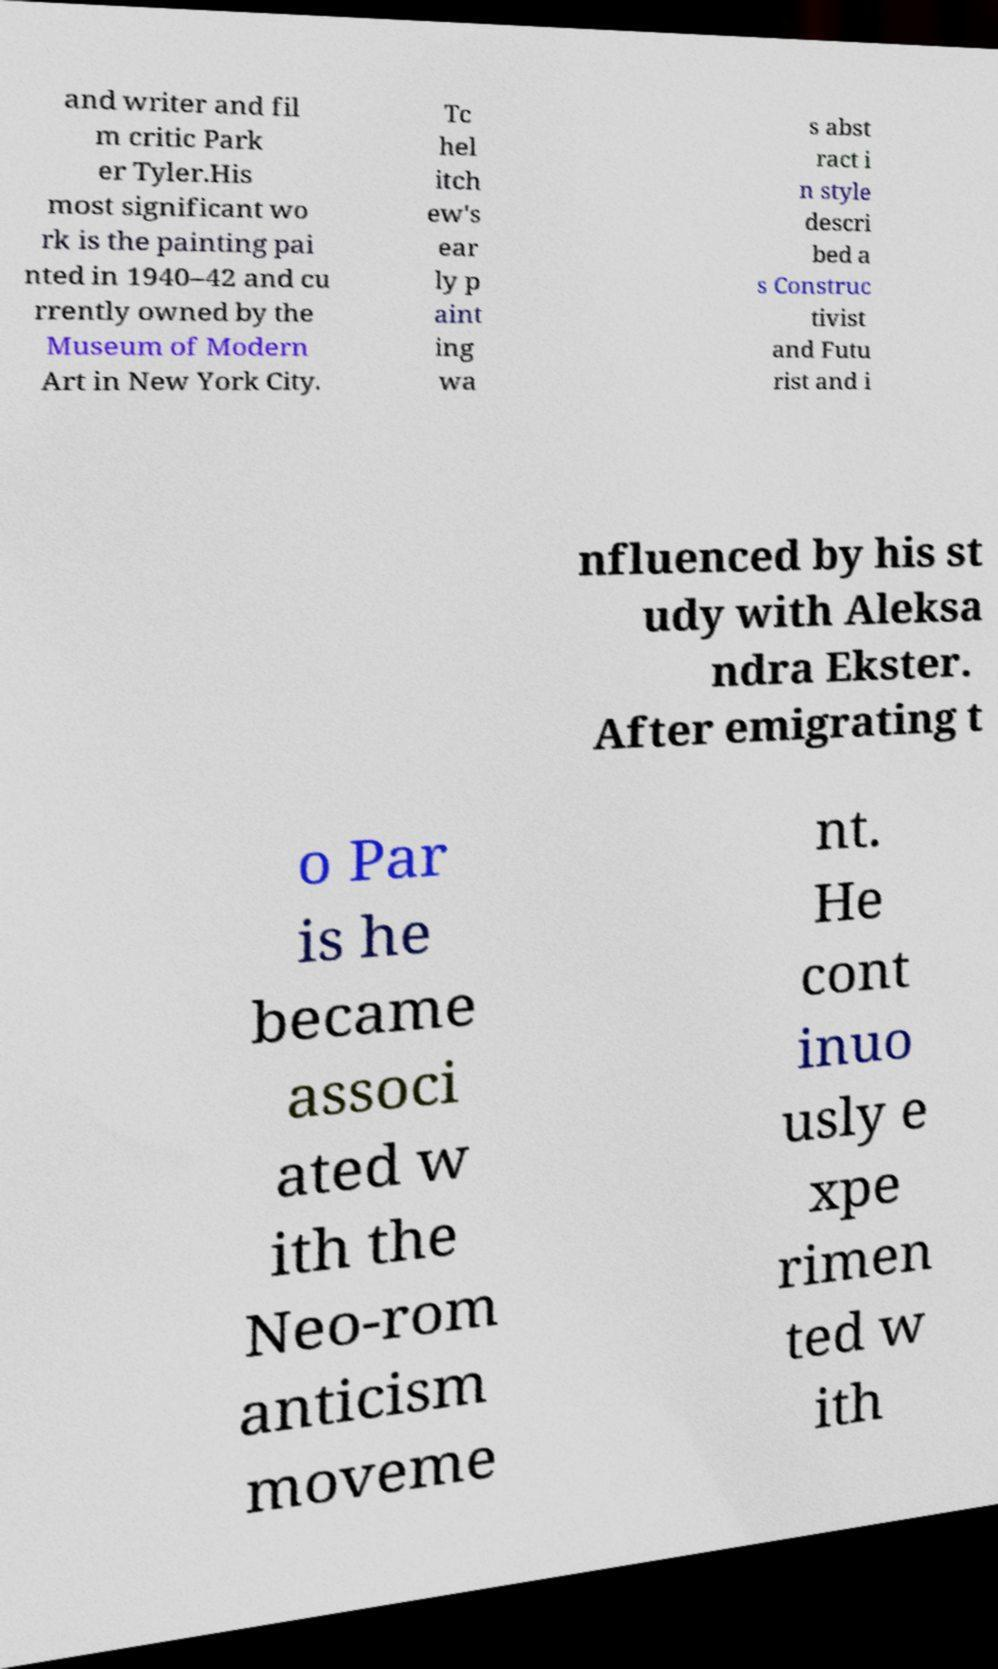There's text embedded in this image that I need extracted. Can you transcribe it verbatim? and writer and fil m critic Park er Tyler.His most significant wo rk is the painting pai nted in 1940–42 and cu rrently owned by the Museum of Modern Art in New York City. Tc hel itch ew's ear ly p aint ing wa s abst ract i n style descri bed a s Construc tivist and Futu rist and i nfluenced by his st udy with Aleksa ndra Ekster. After emigrating t o Par is he became associ ated w ith the Neo-rom anticism moveme nt. He cont inuo usly e xpe rimen ted w ith 